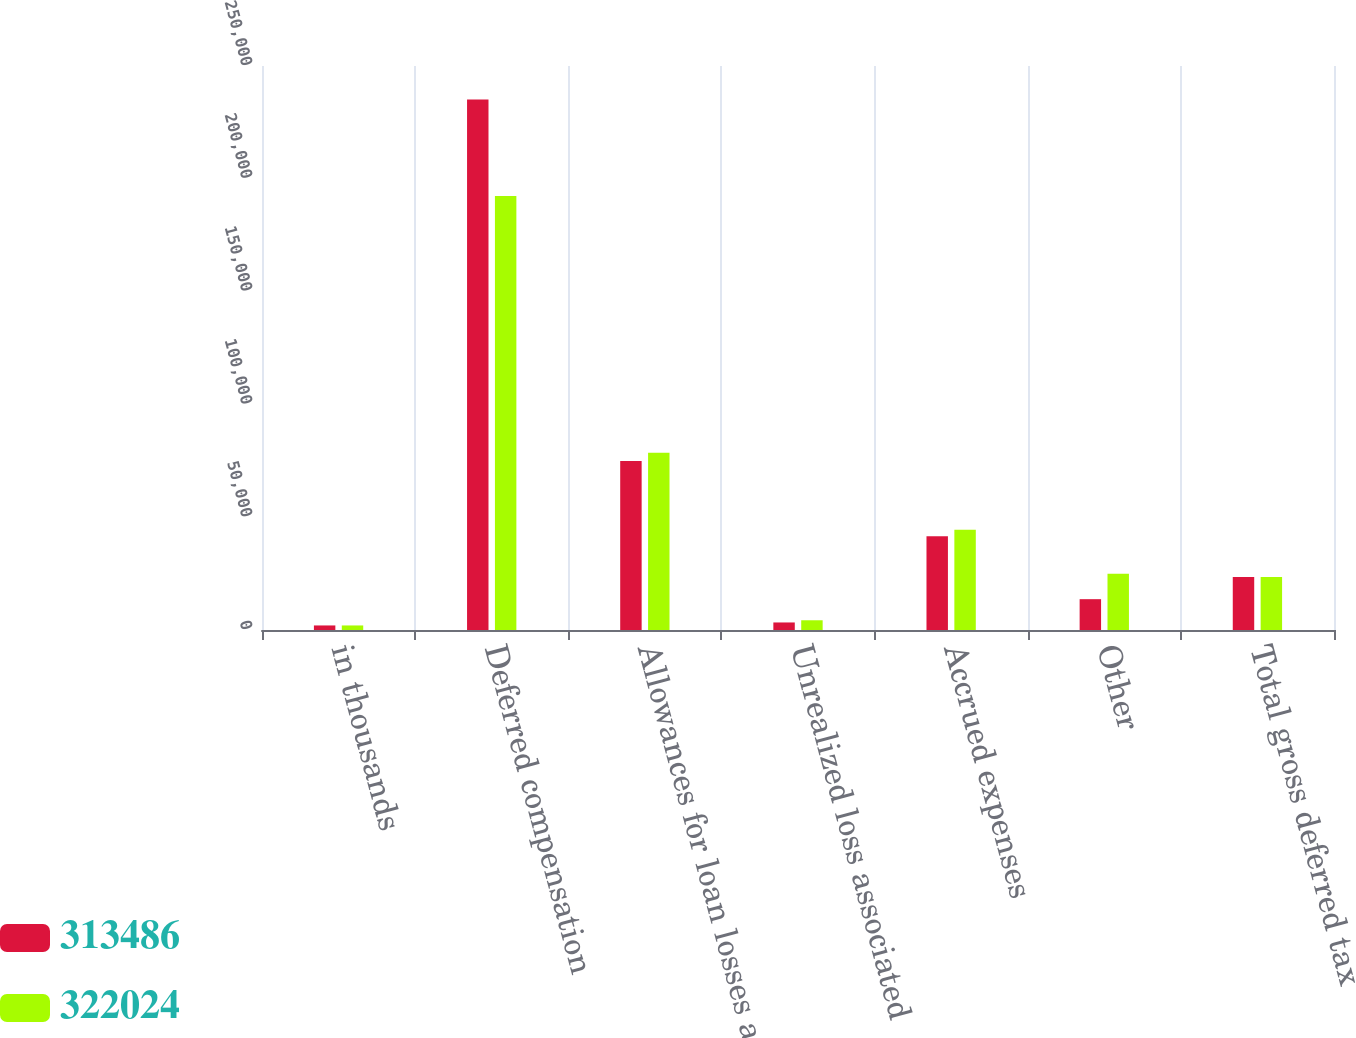<chart> <loc_0><loc_0><loc_500><loc_500><stacked_bar_chart><ecel><fcel>in thousands<fcel>Deferred compensation<fcel>Allowances for loan losses and<fcel>Unrealized loss associated<fcel>Accrued expenses<fcel>Other<fcel>Total gross deferred tax<nl><fcel>313486<fcel>2017<fcel>235171<fcel>74909<fcel>3342<fcel>41545<fcel>13665<fcel>23540.5<nl><fcel>322024<fcel>2016<fcel>192397<fcel>78552<fcel>4314<fcel>44419<fcel>24897<fcel>23540.5<nl></chart> 